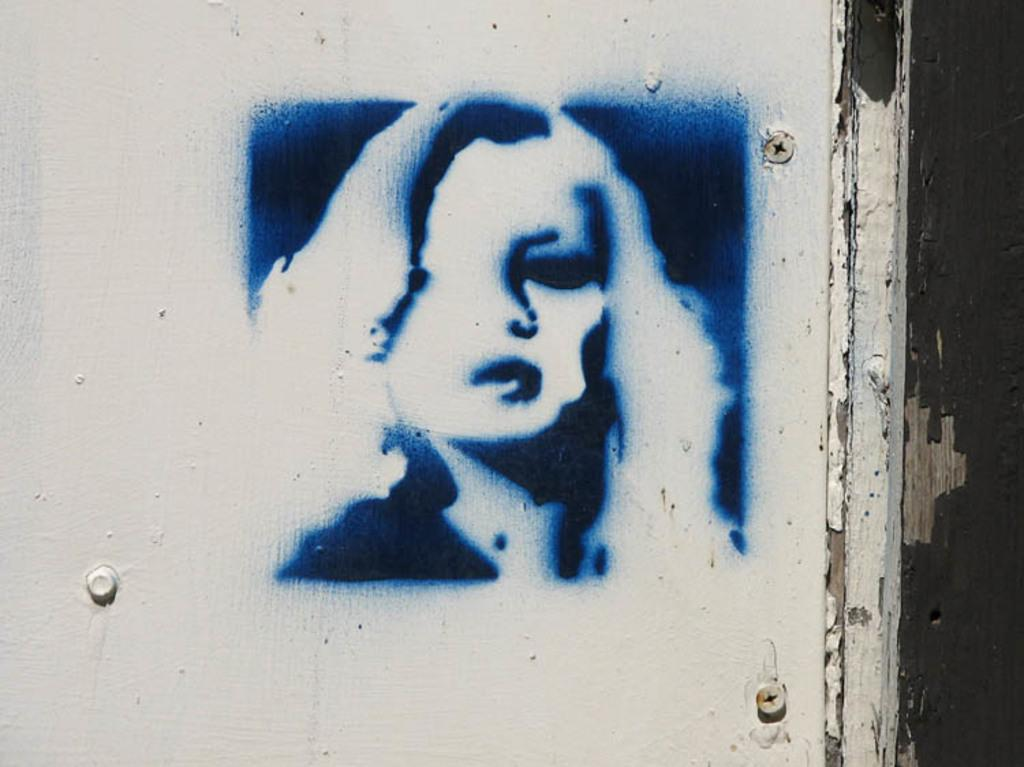What is depicted on the painting that is hanging on the wall? There is a painting of a lady on the wall. What else can be seen on the wall besides the painting? There are screws on the wall. What type of berry is hanging from the painting in the image? There is no berry present in the image, as it features a painting of a lady and screws on the wall. 